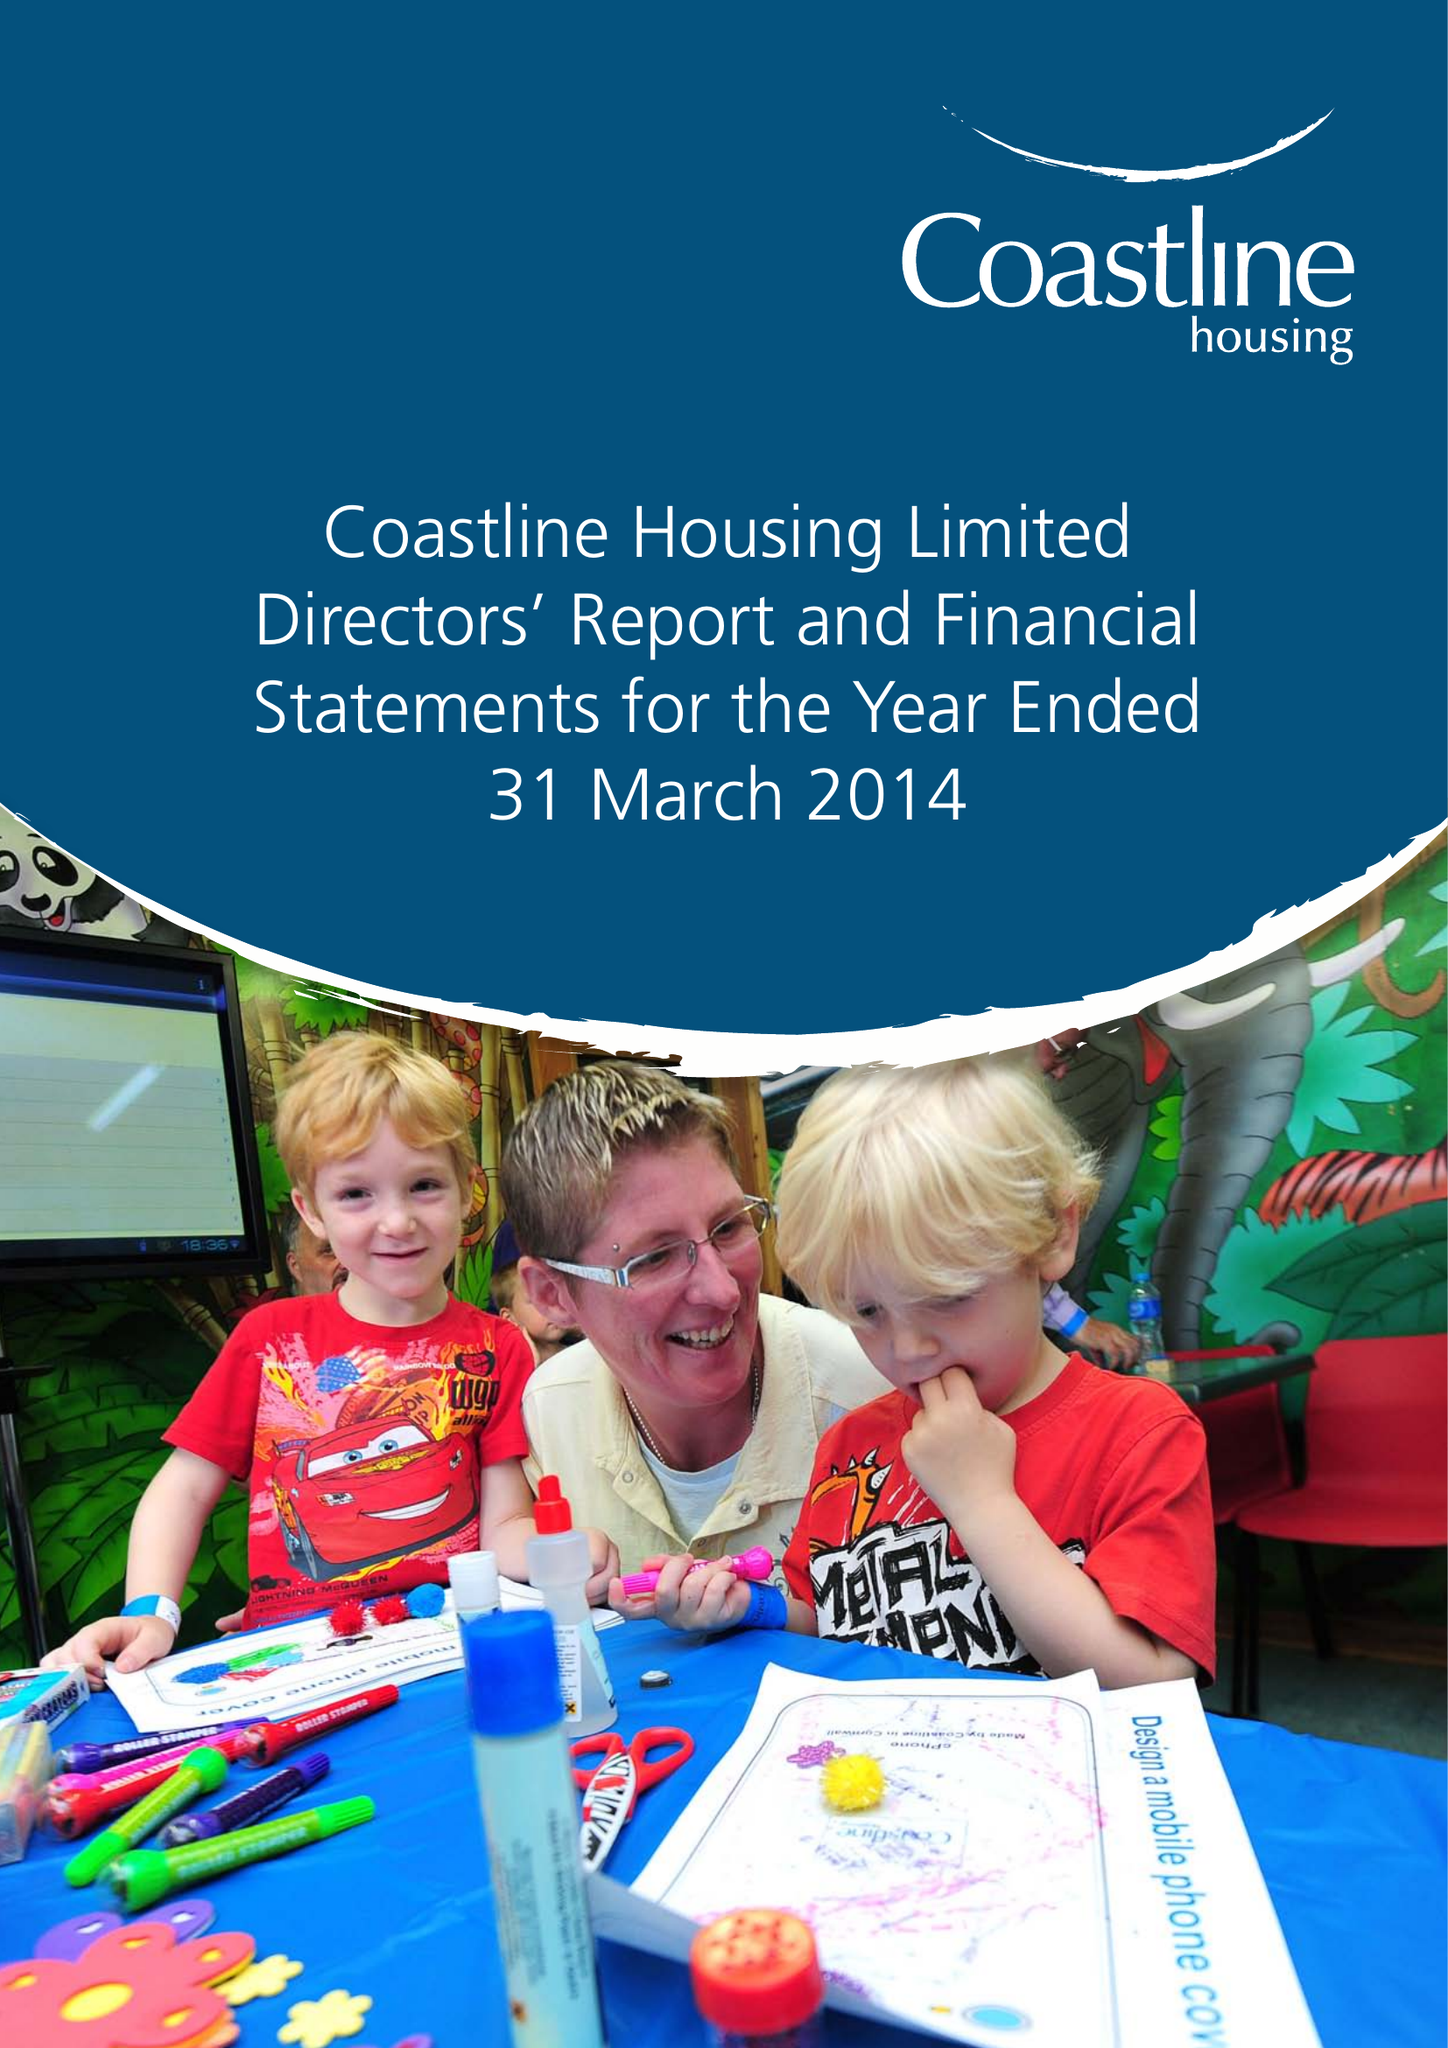What is the value for the spending_annually_in_british_pounds?
Answer the question using a single word or phrase. 15210000.00 